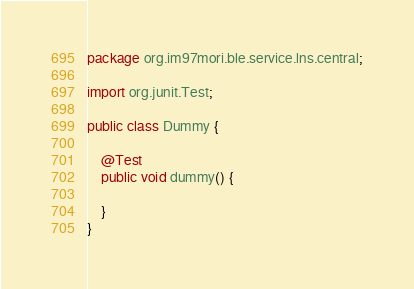<code> <loc_0><loc_0><loc_500><loc_500><_Java_>package org.im97mori.ble.service.lns.central;

import org.junit.Test;

public class Dummy {

    @Test
    public void dummy() {

    }
}
</code> 